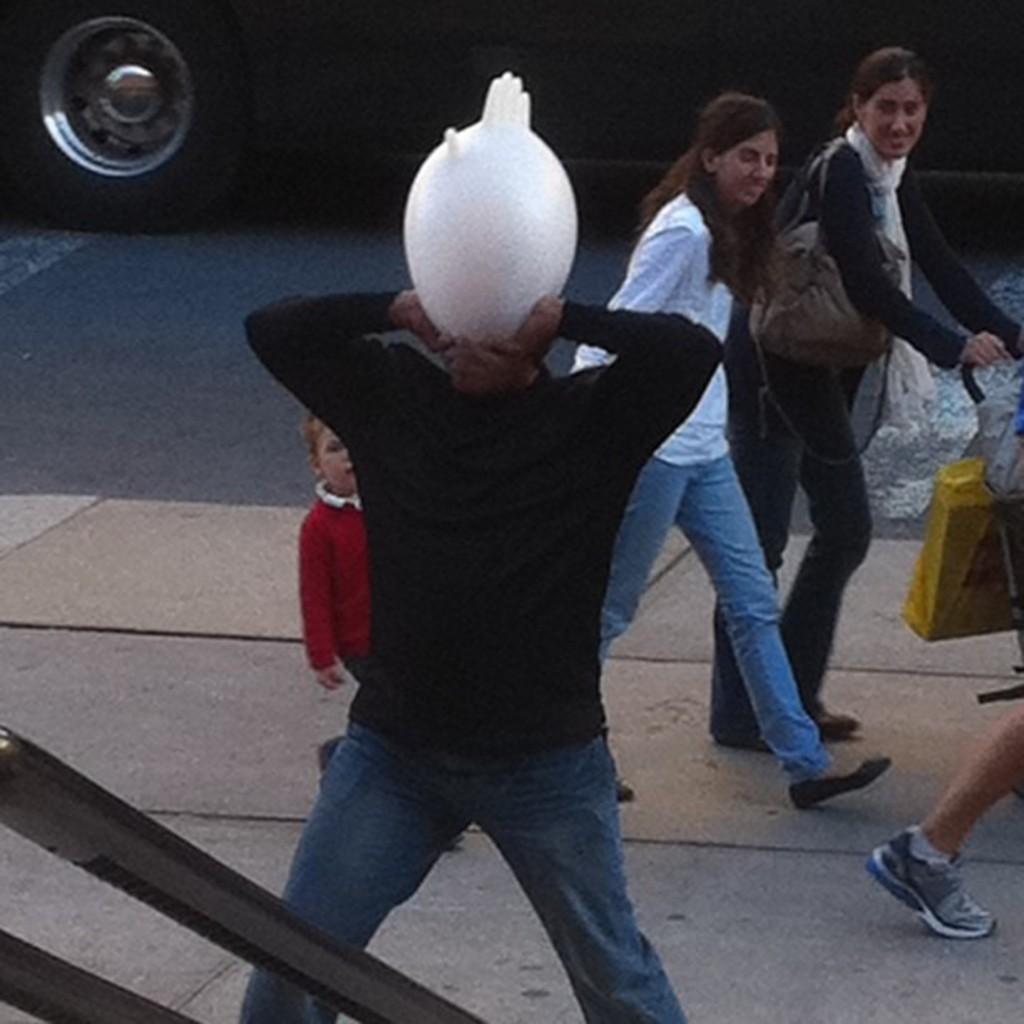Could you give a brief overview of what you see in this image? In this picture there is a person with black jacket is standing and holding the object and there are group of people walking on the footpath. At the back there is a vehicle on the road. In the foreground it looks like a rod. 